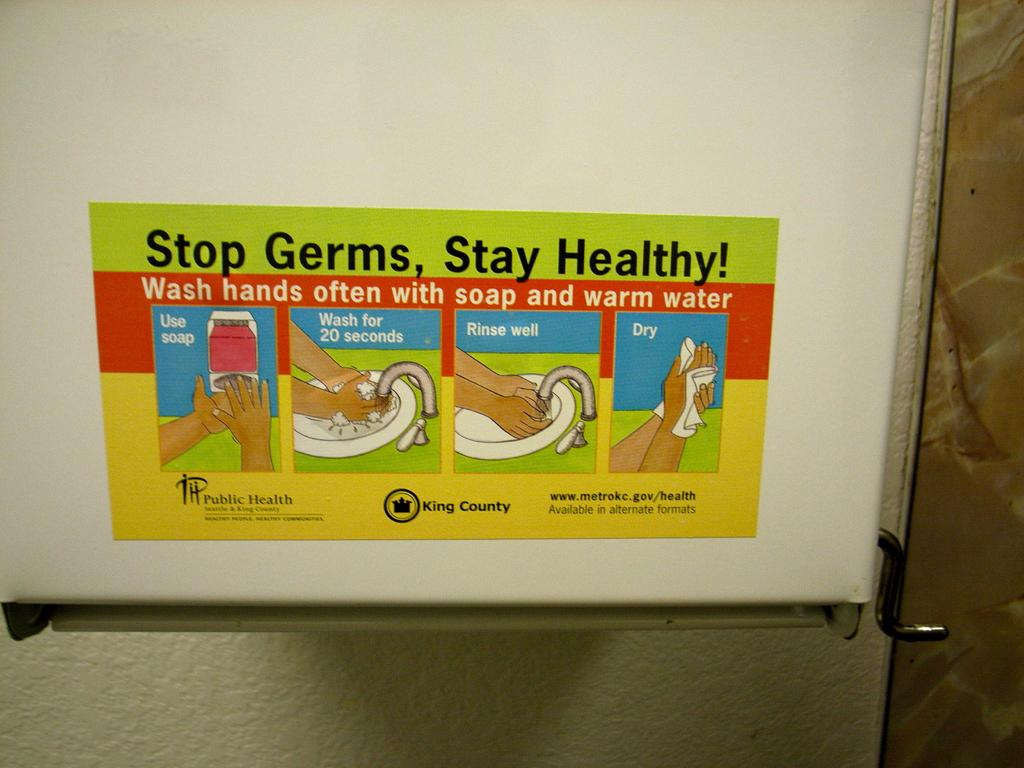Provide a one-sentence caption for the provided image. A sign to stop germs and stay heathy by washing your hands. 